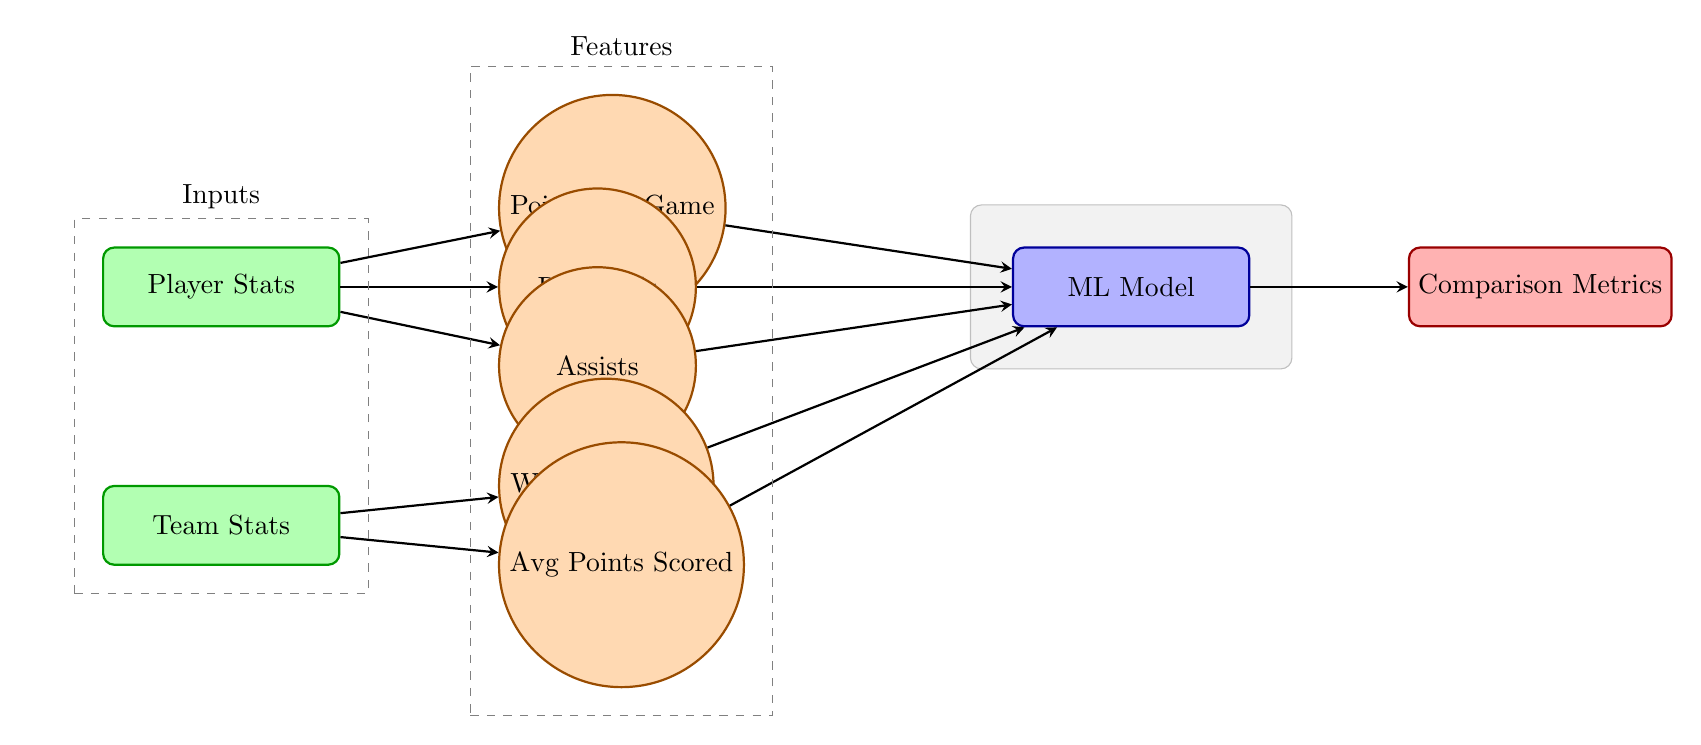What are the two main types of stats represented in the diagram? The diagram includes two main types of stats: "Player Stats" and "Team Stats," which are the two inputs that lead to the computation of metrics.
Answer: Player Stats, Team Stats How many player performance metrics are shown in the diagram? The diagram includes three player performance metrics branching out from "Player Stats": "Points per Game," "Rebounds," and "Assists." Counting these gives a total of three metrics.
Answer: 3 What is the process that combines all statistics in the diagram? The statistics from both player and team metrics are sent to the "ML Model," which serves as the processing node that combines these inputs and processes them for output.
Answer: ML Model Which feature is associated with team performance in the diagram? The features associated with team performance are "Win Percentage" and "Avg Points Scored," which stem from the "Team Stats" input node.
Answer: Win Percentage, Avg Points Scored What is the output of the ML model in this diagram? The output of the ML model is labeled as "Comparison Metrics," which indicates that the results of the model will provide some form of metrics comparing the input stats.
Answer: Comparison Metrics What arrow connections show the relationship between player stats and the ML model? The diagram uses arrows connecting "Points per Game," "Rebounds," and "Assists" directly to the "ML Model," indicating that these metrics are inputs into the model.
Answer: Points per Game, Rebounds, Assists What visual representation indicates the grouping of features in the diagram? The grouping of features is visually indicated by dashed boundary boxes labeled "Inputs" and "Features," which encompass respective nodes associated with player and team statistics.
Answer: Dashed boundary boxes How many total features are derived from both player and team statistics? The diagram displays five individual features: three from player statistics and two from team statistics, resulting in a total of five features.
Answer: 5 